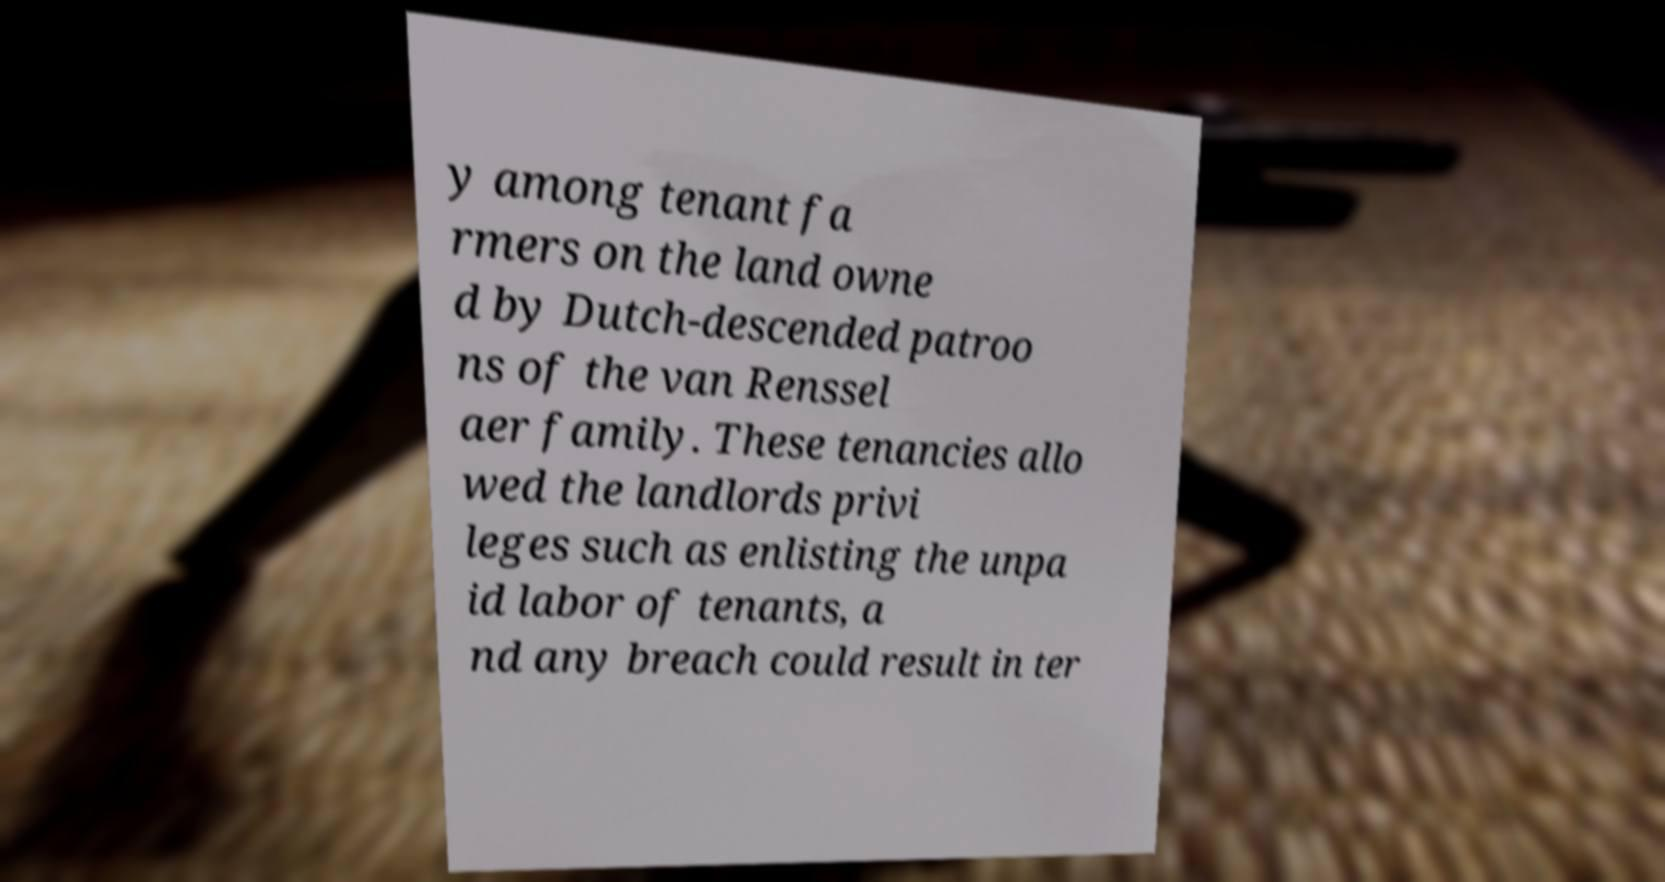Please identify and transcribe the text found in this image. y among tenant fa rmers on the land owne d by Dutch-descended patroo ns of the van Renssel aer family. These tenancies allo wed the landlords privi leges such as enlisting the unpa id labor of tenants, a nd any breach could result in ter 